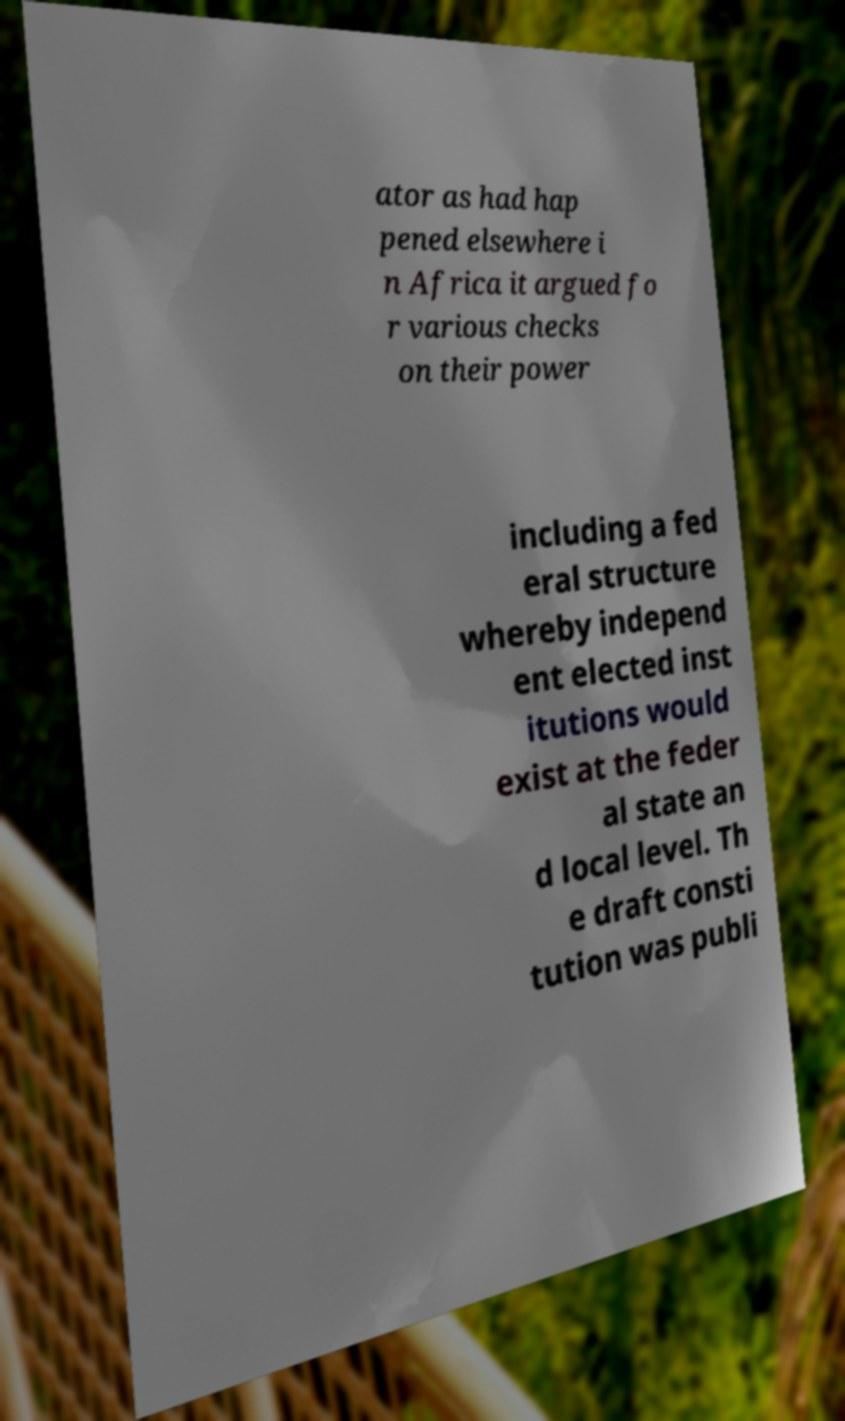I need the written content from this picture converted into text. Can you do that? ator as had hap pened elsewhere i n Africa it argued fo r various checks on their power including a fed eral structure whereby independ ent elected inst itutions would exist at the feder al state an d local level. Th e draft consti tution was publi 